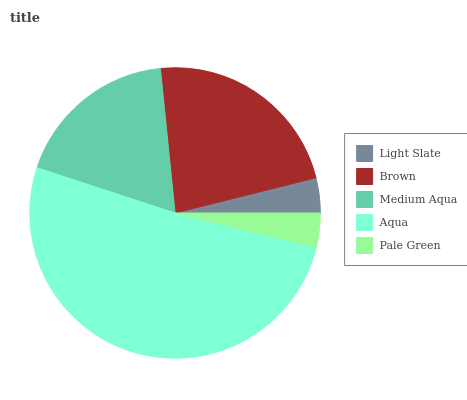Is Pale Green the minimum?
Answer yes or no. Yes. Is Aqua the maximum?
Answer yes or no. Yes. Is Brown the minimum?
Answer yes or no. No. Is Brown the maximum?
Answer yes or no. No. Is Brown greater than Light Slate?
Answer yes or no. Yes. Is Light Slate less than Brown?
Answer yes or no. Yes. Is Light Slate greater than Brown?
Answer yes or no. No. Is Brown less than Light Slate?
Answer yes or no. No. Is Medium Aqua the high median?
Answer yes or no. Yes. Is Medium Aqua the low median?
Answer yes or no. Yes. Is Pale Green the high median?
Answer yes or no. No. Is Brown the low median?
Answer yes or no. No. 